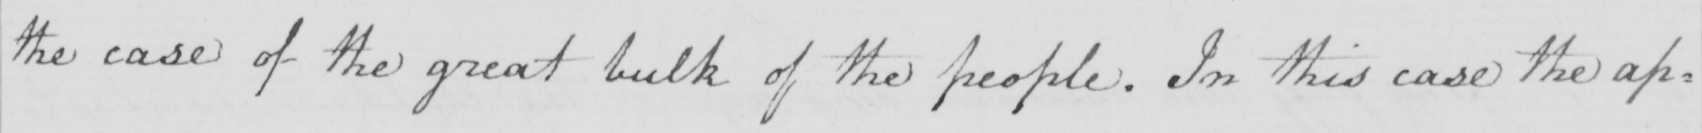Please provide the text content of this handwritten line. the case of the great bulk of the people . In this case the ap= 